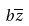<formula> <loc_0><loc_0><loc_500><loc_500>b \overline { z }</formula> 